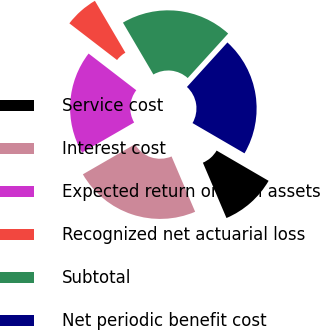Convert chart. <chart><loc_0><loc_0><loc_500><loc_500><pie_chart><fcel>Service cost<fcel>Interest cost<fcel>Expected return on plan assets<fcel>Recognized net actuarial loss<fcel>Subtotal<fcel>Net periodic benefit cost<nl><fcel>10.2%<fcel>23.08%<fcel>18.77%<fcel>6.11%<fcel>20.2%<fcel>21.64%<nl></chart> 